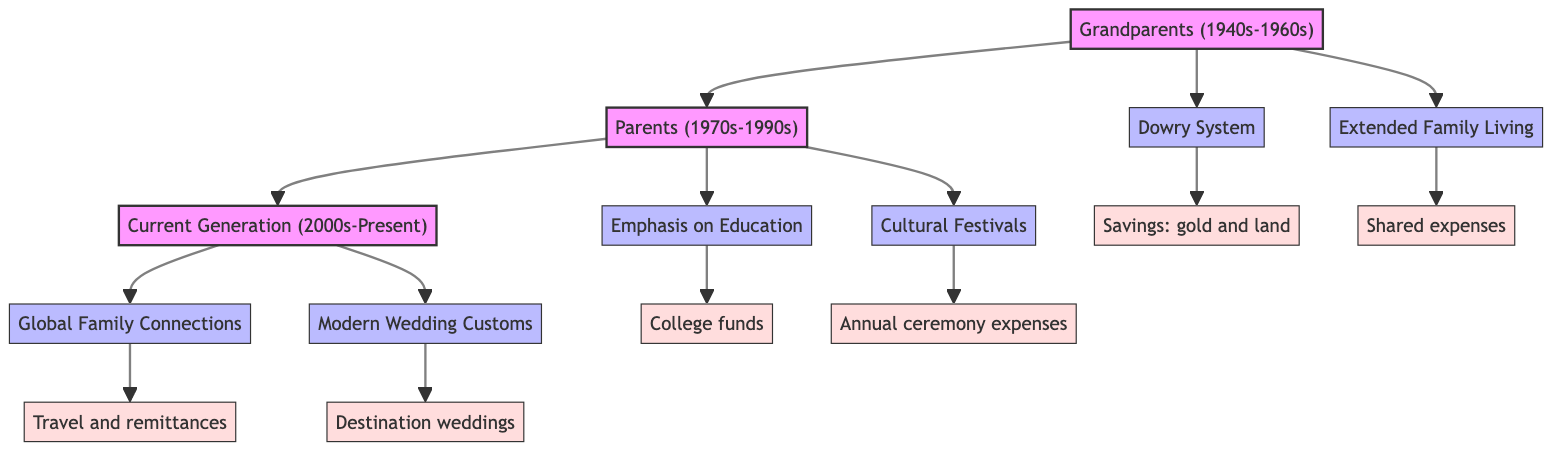What traditions are associated with the Grandparents generation? The Grandparents generation details two traditions: "Dowry System" and "Extended Family Living" shown in the diagram.
Answer: Dowry System, Extended Family Living How many generations are represented in the diagram? The diagram consists of three generations: Grandparents, Parents, and Current Generation, which can be counted directly from the diagram.
Answer: 3 What is the financial implication of the "Cultural Festivals" tradition? The diagram specifies that the "Cultural Festivals" tradition has the financial implication of "Annual expenses for festivals and ceremonies," as shown directly connecting to the festivals tradition node.
Answer: Annual expenses for festivals and ceremonies Which generation placed an emphasis on education? The "Emphasis on Education" tradition is linked to the Parents generation, indicating that this generation particularly highlighted education according to the diagram.
Answer: Parents What is the real entity associated with the "Modern Wedding Customs"? The diagram states that the "Modern Wedding Customs" tradition has "Couples and families spending significantly on wedding planners and exotic locations" as its real entity, connecting directly to this tradition in the diagram.
Answer: Couples and families spending significantly on wedding planners and exotic locations What financial implication is linked to the "Global Family Connections" tradition? According to the diagram, the financial implication linked to the "Global Family Connections" tradition is "Costs related to international travel and remittances," which can be traced from the global connections tradition node.
Answer: Costs related to international travel and remittances Which generation is associated with significant savings for children's college education? The "Emphasis on Education," located under the Parents generation, suggests this generation is responsible for the significant savings directed towards children's college education as depicted in the diagram.
Answer: Parents What shared financial characteristic is highlighted in the Grandparents generation? The "Extended Family Living" tradition is associated with "Shared living expenses and pooled resources," indicating a notable characteristic in terms of finances for the Grandparents generation shown in the diagram.
Answer: Shared living expenses and pooled resources 